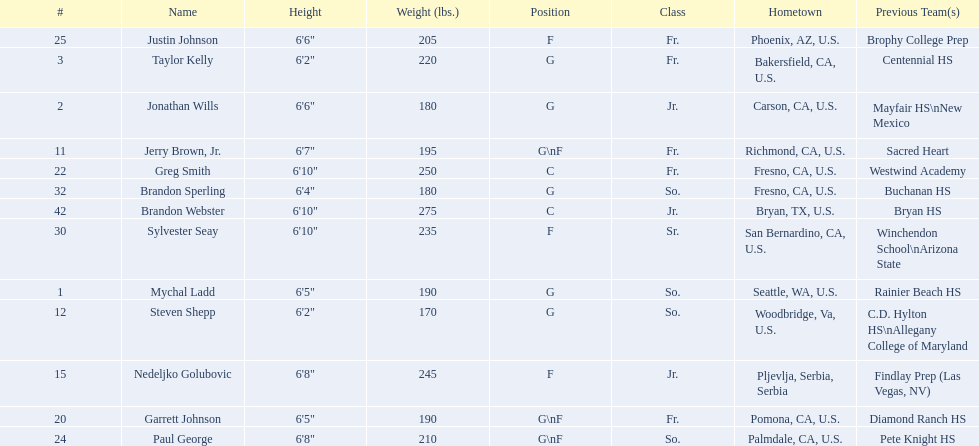What are the names of the basketball team players? Mychal Ladd, Jonathan Wills, Taylor Kelly, Jerry Brown, Jr., Steven Shepp, Nedeljko Golubovic, Garrett Johnson, Greg Smith, Paul George, Justin Johnson, Sylvester Seay, Brandon Sperling, Brandon Webster. Of these identify paul george and greg smith Greg Smith, Paul George. What are their corresponding heights? 6'10", 6'8". To who does the larger height correspond to? Greg Smith. 